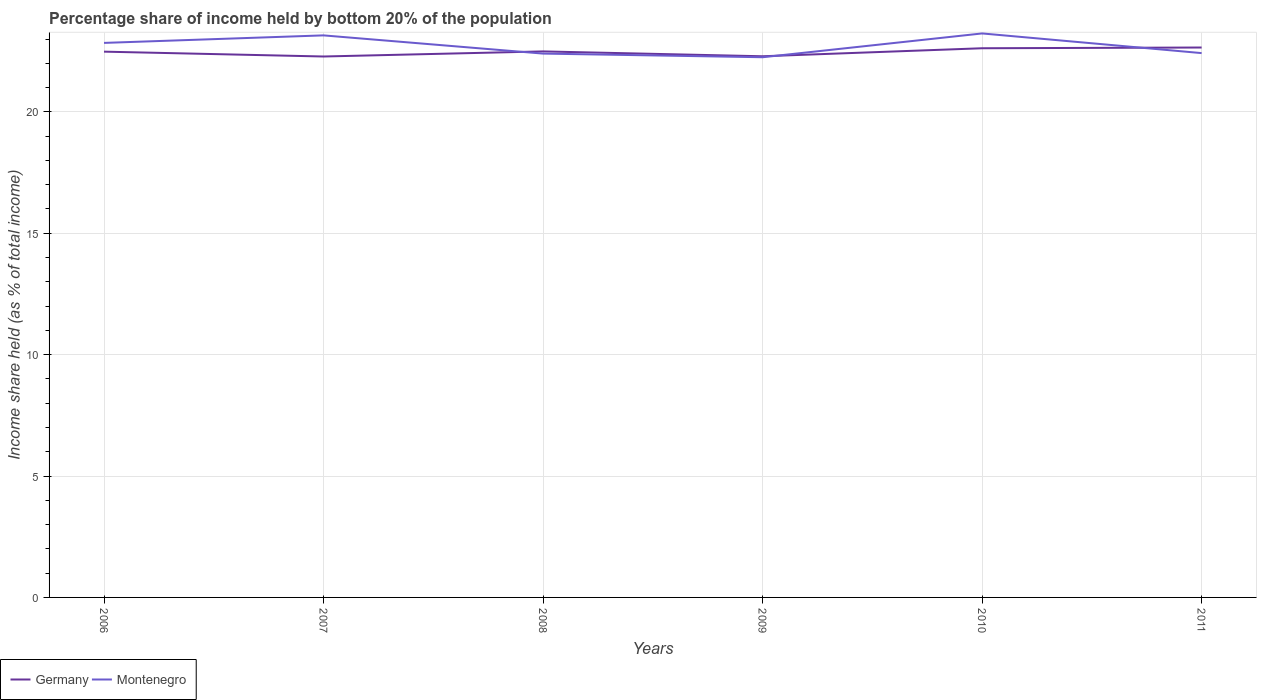How many different coloured lines are there?
Keep it short and to the point. 2. Does the line corresponding to Montenegro intersect with the line corresponding to Germany?
Provide a succinct answer. Yes. Is the number of lines equal to the number of legend labels?
Your answer should be very brief. Yes. Across all years, what is the maximum share of income held by bottom 20% of the population in Germany?
Give a very brief answer. 22.28. In which year was the share of income held by bottom 20% of the population in Montenegro maximum?
Give a very brief answer. 2009. What is the total share of income held by bottom 20% of the population in Montenegro in the graph?
Your response must be concise. -0.17. What is the difference between the highest and the second highest share of income held by bottom 20% of the population in Germany?
Ensure brevity in your answer.  0.37. Is the share of income held by bottom 20% of the population in Montenegro strictly greater than the share of income held by bottom 20% of the population in Germany over the years?
Keep it short and to the point. No. How many years are there in the graph?
Your answer should be compact. 6. What is the difference between two consecutive major ticks on the Y-axis?
Provide a short and direct response. 5. Are the values on the major ticks of Y-axis written in scientific E-notation?
Make the answer very short. No. Does the graph contain any zero values?
Provide a succinct answer. No. Where does the legend appear in the graph?
Your answer should be compact. Bottom left. What is the title of the graph?
Make the answer very short. Percentage share of income held by bottom 20% of the population. What is the label or title of the X-axis?
Offer a terse response. Years. What is the label or title of the Y-axis?
Offer a very short reply. Income share held (as % of total income). What is the Income share held (as % of total income) in Germany in 2006?
Give a very brief answer. 22.48. What is the Income share held (as % of total income) of Montenegro in 2006?
Ensure brevity in your answer.  22.84. What is the Income share held (as % of total income) of Germany in 2007?
Your response must be concise. 22.28. What is the Income share held (as % of total income) of Montenegro in 2007?
Your answer should be very brief. 23.15. What is the Income share held (as % of total income) of Germany in 2008?
Your answer should be compact. 22.49. What is the Income share held (as % of total income) in Montenegro in 2008?
Make the answer very short. 22.4. What is the Income share held (as % of total income) in Germany in 2009?
Your response must be concise. 22.29. What is the Income share held (as % of total income) of Montenegro in 2009?
Ensure brevity in your answer.  22.25. What is the Income share held (as % of total income) of Germany in 2010?
Your response must be concise. 22.62. What is the Income share held (as % of total income) of Montenegro in 2010?
Give a very brief answer. 23.23. What is the Income share held (as % of total income) of Germany in 2011?
Ensure brevity in your answer.  22.65. What is the Income share held (as % of total income) in Montenegro in 2011?
Your response must be concise. 22.42. Across all years, what is the maximum Income share held (as % of total income) of Germany?
Your answer should be compact. 22.65. Across all years, what is the maximum Income share held (as % of total income) in Montenegro?
Provide a short and direct response. 23.23. Across all years, what is the minimum Income share held (as % of total income) of Germany?
Ensure brevity in your answer.  22.28. Across all years, what is the minimum Income share held (as % of total income) in Montenegro?
Your answer should be very brief. 22.25. What is the total Income share held (as % of total income) of Germany in the graph?
Your answer should be compact. 134.81. What is the total Income share held (as % of total income) in Montenegro in the graph?
Your response must be concise. 136.29. What is the difference between the Income share held (as % of total income) of Germany in 2006 and that in 2007?
Provide a succinct answer. 0.2. What is the difference between the Income share held (as % of total income) of Montenegro in 2006 and that in 2007?
Your response must be concise. -0.31. What is the difference between the Income share held (as % of total income) in Germany in 2006 and that in 2008?
Your answer should be very brief. -0.01. What is the difference between the Income share held (as % of total income) of Montenegro in 2006 and that in 2008?
Keep it short and to the point. 0.44. What is the difference between the Income share held (as % of total income) in Germany in 2006 and that in 2009?
Make the answer very short. 0.19. What is the difference between the Income share held (as % of total income) of Montenegro in 2006 and that in 2009?
Your response must be concise. 0.59. What is the difference between the Income share held (as % of total income) in Germany in 2006 and that in 2010?
Give a very brief answer. -0.14. What is the difference between the Income share held (as % of total income) of Montenegro in 2006 and that in 2010?
Ensure brevity in your answer.  -0.39. What is the difference between the Income share held (as % of total income) in Germany in 2006 and that in 2011?
Your response must be concise. -0.17. What is the difference between the Income share held (as % of total income) in Montenegro in 2006 and that in 2011?
Provide a short and direct response. 0.42. What is the difference between the Income share held (as % of total income) in Germany in 2007 and that in 2008?
Your response must be concise. -0.21. What is the difference between the Income share held (as % of total income) of Montenegro in 2007 and that in 2008?
Provide a succinct answer. 0.75. What is the difference between the Income share held (as % of total income) of Germany in 2007 and that in 2009?
Your answer should be very brief. -0.01. What is the difference between the Income share held (as % of total income) in Germany in 2007 and that in 2010?
Your response must be concise. -0.34. What is the difference between the Income share held (as % of total income) of Montenegro in 2007 and that in 2010?
Provide a short and direct response. -0.08. What is the difference between the Income share held (as % of total income) of Germany in 2007 and that in 2011?
Your answer should be very brief. -0.37. What is the difference between the Income share held (as % of total income) in Montenegro in 2007 and that in 2011?
Your answer should be very brief. 0.73. What is the difference between the Income share held (as % of total income) in Montenegro in 2008 and that in 2009?
Your response must be concise. 0.15. What is the difference between the Income share held (as % of total income) of Germany in 2008 and that in 2010?
Offer a very short reply. -0.13. What is the difference between the Income share held (as % of total income) in Montenegro in 2008 and that in 2010?
Give a very brief answer. -0.83. What is the difference between the Income share held (as % of total income) in Germany in 2008 and that in 2011?
Keep it short and to the point. -0.16. What is the difference between the Income share held (as % of total income) of Montenegro in 2008 and that in 2011?
Keep it short and to the point. -0.02. What is the difference between the Income share held (as % of total income) in Germany in 2009 and that in 2010?
Ensure brevity in your answer.  -0.33. What is the difference between the Income share held (as % of total income) in Montenegro in 2009 and that in 2010?
Offer a very short reply. -0.98. What is the difference between the Income share held (as % of total income) of Germany in 2009 and that in 2011?
Your answer should be compact. -0.36. What is the difference between the Income share held (as % of total income) in Montenegro in 2009 and that in 2011?
Offer a terse response. -0.17. What is the difference between the Income share held (as % of total income) of Germany in 2010 and that in 2011?
Offer a terse response. -0.03. What is the difference between the Income share held (as % of total income) of Montenegro in 2010 and that in 2011?
Give a very brief answer. 0.81. What is the difference between the Income share held (as % of total income) of Germany in 2006 and the Income share held (as % of total income) of Montenegro in 2007?
Offer a terse response. -0.67. What is the difference between the Income share held (as % of total income) of Germany in 2006 and the Income share held (as % of total income) of Montenegro in 2009?
Make the answer very short. 0.23. What is the difference between the Income share held (as % of total income) in Germany in 2006 and the Income share held (as % of total income) in Montenegro in 2010?
Offer a terse response. -0.75. What is the difference between the Income share held (as % of total income) of Germany in 2006 and the Income share held (as % of total income) of Montenegro in 2011?
Provide a succinct answer. 0.06. What is the difference between the Income share held (as % of total income) of Germany in 2007 and the Income share held (as % of total income) of Montenegro in 2008?
Your answer should be compact. -0.12. What is the difference between the Income share held (as % of total income) of Germany in 2007 and the Income share held (as % of total income) of Montenegro in 2009?
Your answer should be very brief. 0.03. What is the difference between the Income share held (as % of total income) in Germany in 2007 and the Income share held (as % of total income) in Montenegro in 2010?
Make the answer very short. -0.95. What is the difference between the Income share held (as % of total income) of Germany in 2007 and the Income share held (as % of total income) of Montenegro in 2011?
Keep it short and to the point. -0.14. What is the difference between the Income share held (as % of total income) in Germany in 2008 and the Income share held (as % of total income) in Montenegro in 2009?
Give a very brief answer. 0.24. What is the difference between the Income share held (as % of total income) in Germany in 2008 and the Income share held (as % of total income) in Montenegro in 2010?
Make the answer very short. -0.74. What is the difference between the Income share held (as % of total income) in Germany in 2008 and the Income share held (as % of total income) in Montenegro in 2011?
Your answer should be very brief. 0.07. What is the difference between the Income share held (as % of total income) of Germany in 2009 and the Income share held (as % of total income) of Montenegro in 2010?
Make the answer very short. -0.94. What is the difference between the Income share held (as % of total income) of Germany in 2009 and the Income share held (as % of total income) of Montenegro in 2011?
Ensure brevity in your answer.  -0.13. What is the difference between the Income share held (as % of total income) of Germany in 2010 and the Income share held (as % of total income) of Montenegro in 2011?
Your answer should be compact. 0.2. What is the average Income share held (as % of total income) of Germany per year?
Provide a succinct answer. 22.47. What is the average Income share held (as % of total income) in Montenegro per year?
Keep it short and to the point. 22.71. In the year 2006, what is the difference between the Income share held (as % of total income) in Germany and Income share held (as % of total income) in Montenegro?
Keep it short and to the point. -0.36. In the year 2007, what is the difference between the Income share held (as % of total income) in Germany and Income share held (as % of total income) in Montenegro?
Offer a terse response. -0.87. In the year 2008, what is the difference between the Income share held (as % of total income) in Germany and Income share held (as % of total income) in Montenegro?
Keep it short and to the point. 0.09. In the year 2009, what is the difference between the Income share held (as % of total income) in Germany and Income share held (as % of total income) in Montenegro?
Give a very brief answer. 0.04. In the year 2010, what is the difference between the Income share held (as % of total income) of Germany and Income share held (as % of total income) of Montenegro?
Provide a short and direct response. -0.61. In the year 2011, what is the difference between the Income share held (as % of total income) in Germany and Income share held (as % of total income) in Montenegro?
Keep it short and to the point. 0.23. What is the ratio of the Income share held (as % of total income) of Germany in 2006 to that in 2007?
Provide a short and direct response. 1.01. What is the ratio of the Income share held (as % of total income) in Montenegro in 2006 to that in 2007?
Give a very brief answer. 0.99. What is the ratio of the Income share held (as % of total income) of Germany in 2006 to that in 2008?
Keep it short and to the point. 1. What is the ratio of the Income share held (as % of total income) in Montenegro in 2006 to that in 2008?
Provide a short and direct response. 1.02. What is the ratio of the Income share held (as % of total income) in Germany in 2006 to that in 2009?
Offer a very short reply. 1.01. What is the ratio of the Income share held (as % of total income) of Montenegro in 2006 to that in 2009?
Offer a terse response. 1.03. What is the ratio of the Income share held (as % of total income) of Germany in 2006 to that in 2010?
Offer a terse response. 0.99. What is the ratio of the Income share held (as % of total income) in Montenegro in 2006 to that in 2010?
Offer a very short reply. 0.98. What is the ratio of the Income share held (as % of total income) of Montenegro in 2006 to that in 2011?
Your answer should be very brief. 1.02. What is the ratio of the Income share held (as % of total income) in Germany in 2007 to that in 2008?
Provide a succinct answer. 0.99. What is the ratio of the Income share held (as % of total income) of Montenegro in 2007 to that in 2008?
Give a very brief answer. 1.03. What is the ratio of the Income share held (as % of total income) of Montenegro in 2007 to that in 2009?
Provide a succinct answer. 1.04. What is the ratio of the Income share held (as % of total income) in Montenegro in 2007 to that in 2010?
Your response must be concise. 1. What is the ratio of the Income share held (as % of total income) of Germany in 2007 to that in 2011?
Offer a terse response. 0.98. What is the ratio of the Income share held (as % of total income) of Montenegro in 2007 to that in 2011?
Keep it short and to the point. 1.03. What is the ratio of the Income share held (as % of total income) in Germany in 2008 to that in 2010?
Provide a short and direct response. 0.99. What is the ratio of the Income share held (as % of total income) in Montenegro in 2008 to that in 2010?
Keep it short and to the point. 0.96. What is the ratio of the Income share held (as % of total income) in Germany in 2008 to that in 2011?
Your response must be concise. 0.99. What is the ratio of the Income share held (as % of total income) of Montenegro in 2008 to that in 2011?
Your answer should be compact. 1. What is the ratio of the Income share held (as % of total income) in Germany in 2009 to that in 2010?
Ensure brevity in your answer.  0.99. What is the ratio of the Income share held (as % of total income) of Montenegro in 2009 to that in 2010?
Keep it short and to the point. 0.96. What is the ratio of the Income share held (as % of total income) in Germany in 2009 to that in 2011?
Make the answer very short. 0.98. What is the ratio of the Income share held (as % of total income) in Germany in 2010 to that in 2011?
Your answer should be very brief. 1. What is the ratio of the Income share held (as % of total income) in Montenegro in 2010 to that in 2011?
Provide a short and direct response. 1.04. What is the difference between the highest and the second highest Income share held (as % of total income) of Germany?
Your answer should be compact. 0.03. What is the difference between the highest and the lowest Income share held (as % of total income) of Germany?
Your response must be concise. 0.37. 